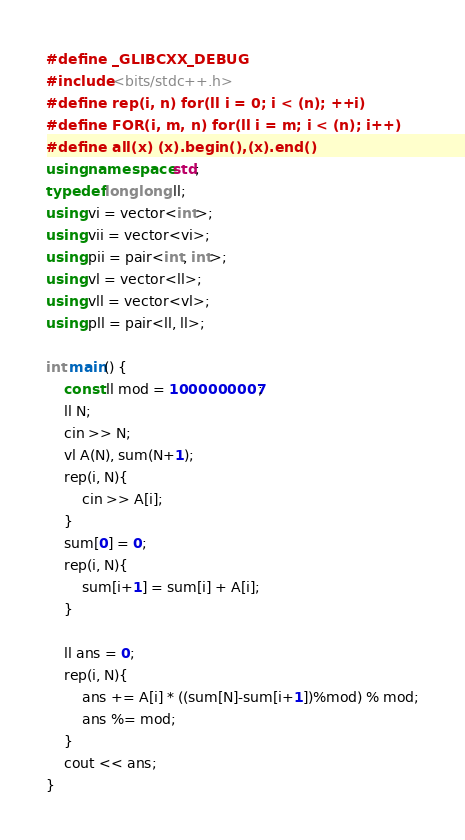Convert code to text. <code><loc_0><loc_0><loc_500><loc_500><_C++_>#define _GLIBCXX_DEBUG
#include <bits/stdc++.h>
#define rep(i, n) for(ll i = 0; i < (n); ++i)
#define FOR(i, m, n) for(ll i = m; i < (n); i++)
#define all(x) (x).begin(),(x).end()
using namespace std;
typedef long long ll;
using vi = vector<int>;
using vii = vector<vi>;
using pii = pair<int, int>; 
using vl = vector<ll>;
using vll = vector<vl>;
using pll = pair<ll, ll>;

int main() {
    const ll mod = 1000000007;
    ll N;
    cin >> N;
    vl A(N), sum(N+1);
    rep(i, N){
        cin >> A[i];
    }
    sum[0] = 0;
    rep(i, N){
        sum[i+1] = sum[i] + A[i];
    }

    ll ans = 0;
    rep(i, N){
        ans += A[i] * ((sum[N]-sum[i+1])%mod) % mod;
        ans %= mod;
    }
    cout << ans;
}
</code> 